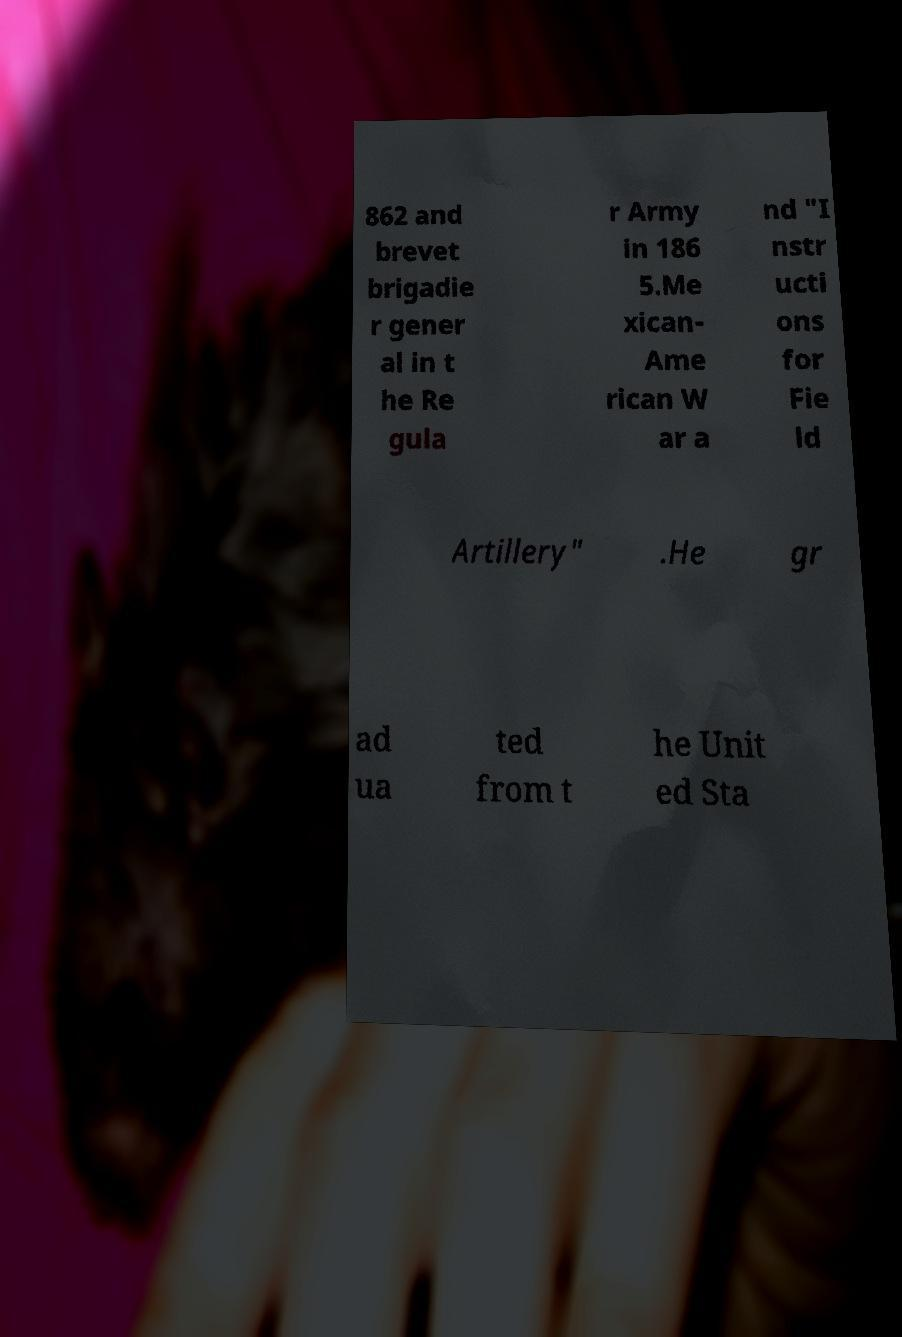There's text embedded in this image that I need extracted. Can you transcribe it verbatim? 862 and brevet brigadie r gener al in t he Re gula r Army in 186 5.Me xican- Ame rican W ar a nd "I nstr ucti ons for Fie ld Artillery" .He gr ad ua ted from t he Unit ed Sta 